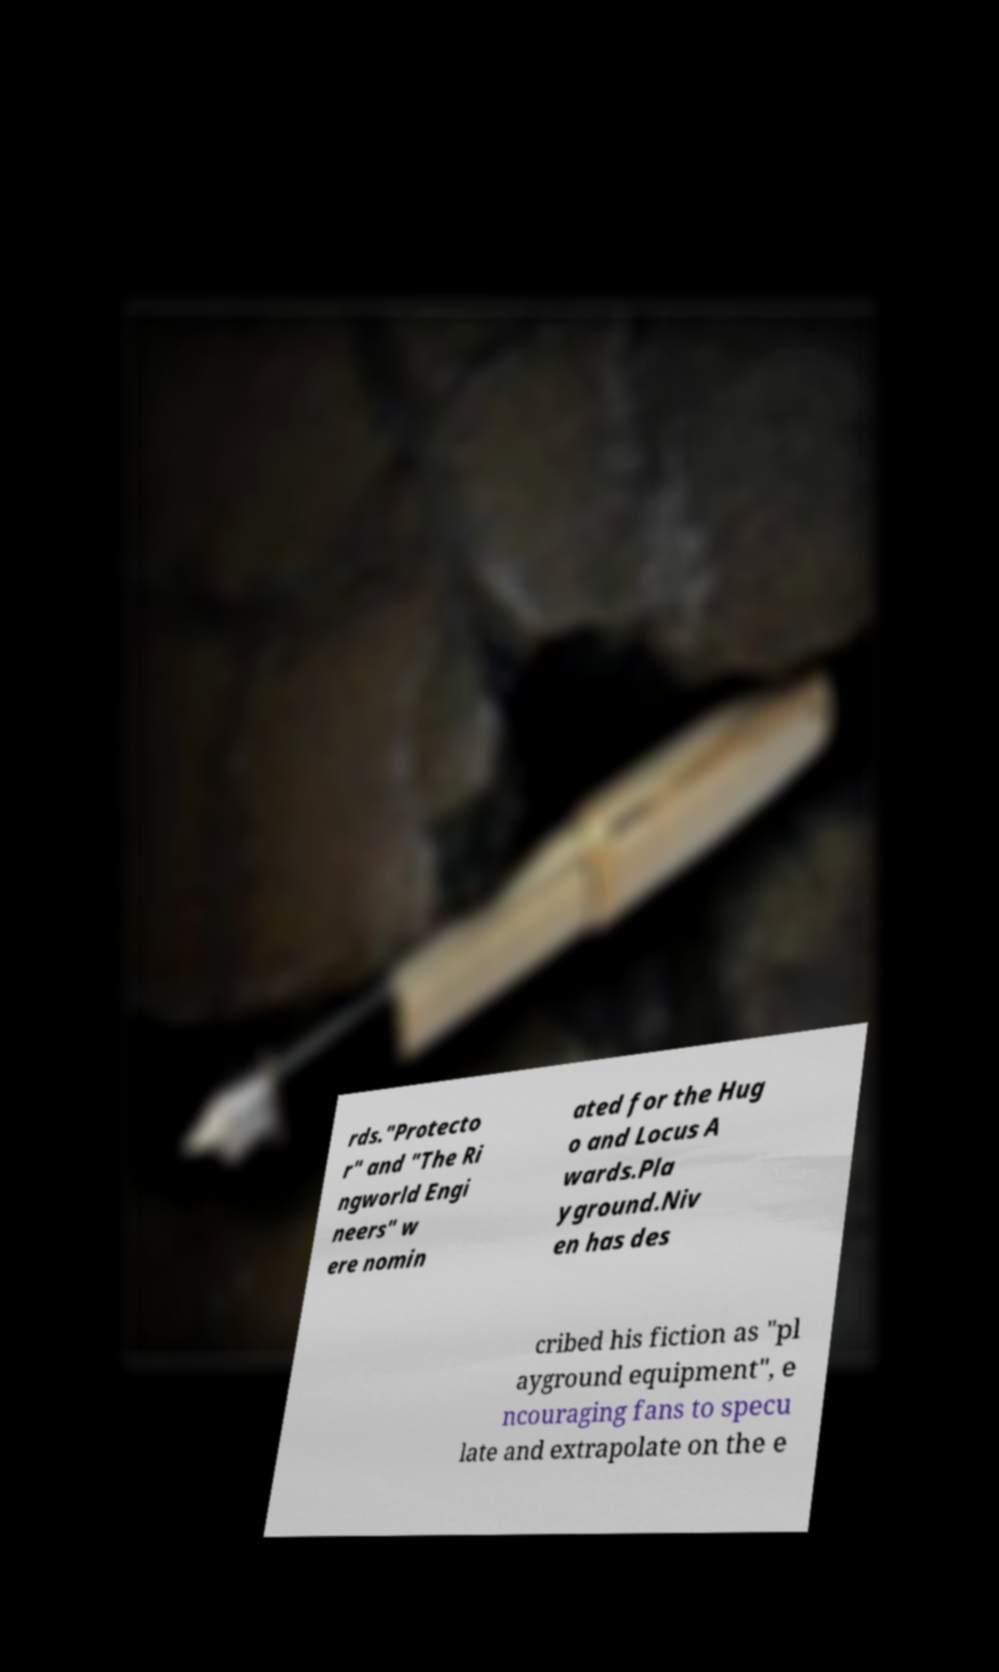Can you read and provide the text displayed in the image?This photo seems to have some interesting text. Can you extract and type it out for me? rds."Protecto r" and "The Ri ngworld Engi neers" w ere nomin ated for the Hug o and Locus A wards.Pla yground.Niv en has des cribed his fiction as "pl ayground equipment", e ncouraging fans to specu late and extrapolate on the e 